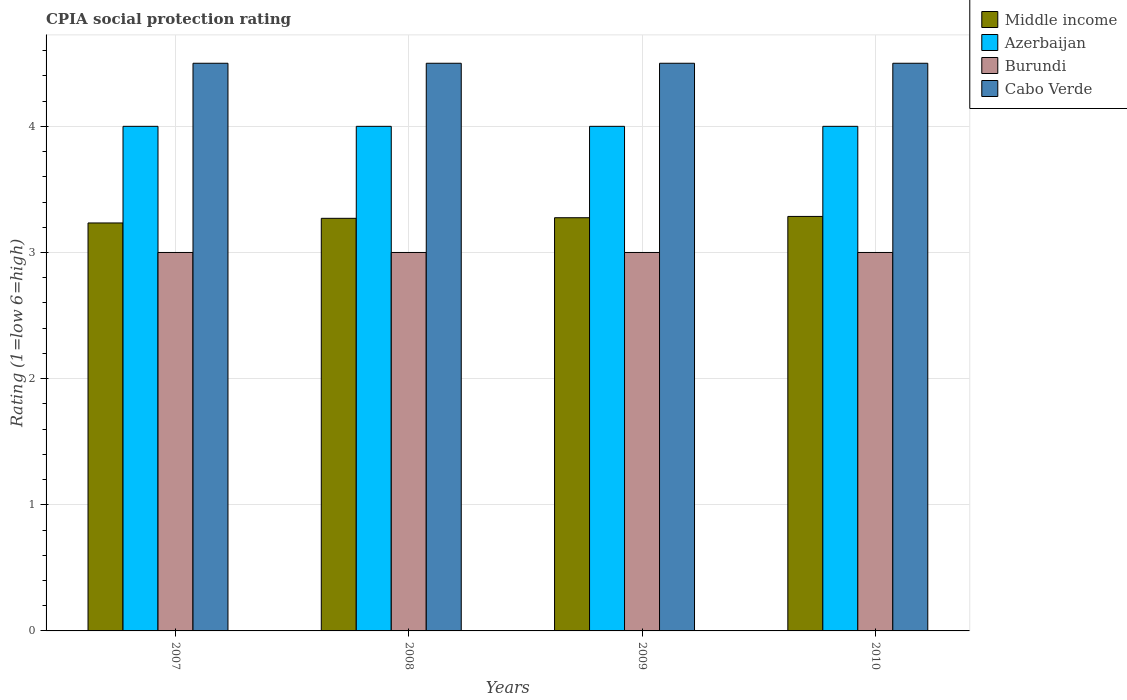Are the number of bars per tick equal to the number of legend labels?
Make the answer very short. Yes. What is the label of the 4th group of bars from the left?
Give a very brief answer. 2010. In which year was the CPIA rating in Cabo Verde maximum?
Keep it short and to the point. 2007. What is the total CPIA rating in Burundi in the graph?
Provide a short and direct response. 12. What is the difference between the CPIA rating in Azerbaijan in 2008 and that in 2010?
Your answer should be compact. 0. What is the difference between the CPIA rating in Cabo Verde in 2008 and the CPIA rating in Azerbaijan in 2009?
Give a very brief answer. 0.5. What is the average CPIA rating in Middle income per year?
Your answer should be very brief. 3.27. In the year 2007, what is the difference between the CPIA rating in Middle income and CPIA rating in Azerbaijan?
Your answer should be compact. -0.77. What is the ratio of the CPIA rating in Middle income in 2007 to that in 2008?
Make the answer very short. 0.99. What is the difference between the highest and the lowest CPIA rating in Middle income?
Offer a terse response. 0.05. In how many years, is the CPIA rating in Azerbaijan greater than the average CPIA rating in Azerbaijan taken over all years?
Offer a terse response. 0. Is the sum of the CPIA rating in Cabo Verde in 2007 and 2008 greater than the maximum CPIA rating in Burundi across all years?
Offer a terse response. Yes. What does the 1st bar from the left in 2007 represents?
Your answer should be compact. Middle income. What does the 1st bar from the right in 2008 represents?
Provide a short and direct response. Cabo Verde. How many bars are there?
Provide a succinct answer. 16. Are all the bars in the graph horizontal?
Ensure brevity in your answer.  No. How many years are there in the graph?
Keep it short and to the point. 4. What is the difference between two consecutive major ticks on the Y-axis?
Offer a very short reply. 1. Are the values on the major ticks of Y-axis written in scientific E-notation?
Keep it short and to the point. No. Where does the legend appear in the graph?
Your answer should be compact. Top right. How many legend labels are there?
Your answer should be very brief. 4. How are the legend labels stacked?
Your response must be concise. Vertical. What is the title of the graph?
Your answer should be compact. CPIA social protection rating. What is the label or title of the X-axis?
Keep it short and to the point. Years. What is the label or title of the Y-axis?
Your answer should be very brief. Rating (1=low 6=high). What is the Rating (1=low 6=high) in Middle income in 2007?
Ensure brevity in your answer.  3.23. What is the Rating (1=low 6=high) of Middle income in 2008?
Offer a terse response. 3.27. What is the Rating (1=low 6=high) of Azerbaijan in 2008?
Keep it short and to the point. 4. What is the Rating (1=low 6=high) in Burundi in 2008?
Your response must be concise. 3. What is the Rating (1=low 6=high) of Cabo Verde in 2008?
Make the answer very short. 4.5. What is the Rating (1=low 6=high) of Middle income in 2009?
Keep it short and to the point. 3.28. What is the Rating (1=low 6=high) in Burundi in 2009?
Give a very brief answer. 3. What is the Rating (1=low 6=high) of Middle income in 2010?
Provide a succinct answer. 3.29. What is the Rating (1=low 6=high) of Azerbaijan in 2010?
Provide a short and direct response. 4. Across all years, what is the maximum Rating (1=low 6=high) of Middle income?
Offer a very short reply. 3.29. Across all years, what is the minimum Rating (1=low 6=high) in Middle income?
Your answer should be compact. 3.23. Across all years, what is the minimum Rating (1=low 6=high) in Burundi?
Offer a terse response. 3. Across all years, what is the minimum Rating (1=low 6=high) in Cabo Verde?
Keep it short and to the point. 4.5. What is the total Rating (1=low 6=high) in Middle income in the graph?
Your response must be concise. 13.07. What is the total Rating (1=low 6=high) in Azerbaijan in the graph?
Your answer should be compact. 16. What is the total Rating (1=low 6=high) in Cabo Verde in the graph?
Make the answer very short. 18. What is the difference between the Rating (1=low 6=high) in Middle income in 2007 and that in 2008?
Provide a short and direct response. -0.04. What is the difference between the Rating (1=low 6=high) in Burundi in 2007 and that in 2008?
Your response must be concise. 0. What is the difference between the Rating (1=low 6=high) of Middle income in 2007 and that in 2009?
Your response must be concise. -0.04. What is the difference between the Rating (1=low 6=high) in Burundi in 2007 and that in 2009?
Offer a very short reply. 0. What is the difference between the Rating (1=low 6=high) in Middle income in 2007 and that in 2010?
Your answer should be very brief. -0.05. What is the difference between the Rating (1=low 6=high) in Azerbaijan in 2007 and that in 2010?
Your answer should be compact. 0. What is the difference between the Rating (1=low 6=high) in Middle income in 2008 and that in 2009?
Keep it short and to the point. -0. What is the difference between the Rating (1=low 6=high) of Azerbaijan in 2008 and that in 2009?
Offer a terse response. 0. What is the difference between the Rating (1=low 6=high) in Burundi in 2008 and that in 2009?
Your answer should be compact. 0. What is the difference between the Rating (1=low 6=high) in Cabo Verde in 2008 and that in 2009?
Make the answer very short. 0. What is the difference between the Rating (1=low 6=high) of Middle income in 2008 and that in 2010?
Provide a short and direct response. -0.01. What is the difference between the Rating (1=low 6=high) of Azerbaijan in 2008 and that in 2010?
Offer a terse response. 0. What is the difference between the Rating (1=low 6=high) of Middle income in 2009 and that in 2010?
Your answer should be compact. -0.01. What is the difference between the Rating (1=low 6=high) of Azerbaijan in 2009 and that in 2010?
Keep it short and to the point. 0. What is the difference between the Rating (1=low 6=high) in Burundi in 2009 and that in 2010?
Provide a short and direct response. 0. What is the difference between the Rating (1=low 6=high) in Middle income in 2007 and the Rating (1=low 6=high) in Azerbaijan in 2008?
Your answer should be compact. -0.77. What is the difference between the Rating (1=low 6=high) of Middle income in 2007 and the Rating (1=low 6=high) of Burundi in 2008?
Offer a terse response. 0.23. What is the difference between the Rating (1=low 6=high) of Middle income in 2007 and the Rating (1=low 6=high) of Cabo Verde in 2008?
Provide a short and direct response. -1.27. What is the difference between the Rating (1=low 6=high) in Azerbaijan in 2007 and the Rating (1=low 6=high) in Cabo Verde in 2008?
Your answer should be compact. -0.5. What is the difference between the Rating (1=low 6=high) in Middle income in 2007 and the Rating (1=low 6=high) in Azerbaijan in 2009?
Offer a terse response. -0.77. What is the difference between the Rating (1=low 6=high) of Middle income in 2007 and the Rating (1=low 6=high) of Burundi in 2009?
Provide a succinct answer. 0.23. What is the difference between the Rating (1=low 6=high) of Middle income in 2007 and the Rating (1=low 6=high) of Cabo Verde in 2009?
Keep it short and to the point. -1.27. What is the difference between the Rating (1=low 6=high) of Azerbaijan in 2007 and the Rating (1=low 6=high) of Cabo Verde in 2009?
Provide a short and direct response. -0.5. What is the difference between the Rating (1=low 6=high) of Middle income in 2007 and the Rating (1=low 6=high) of Azerbaijan in 2010?
Make the answer very short. -0.77. What is the difference between the Rating (1=low 6=high) of Middle income in 2007 and the Rating (1=low 6=high) of Burundi in 2010?
Your answer should be very brief. 0.23. What is the difference between the Rating (1=low 6=high) of Middle income in 2007 and the Rating (1=low 6=high) of Cabo Verde in 2010?
Offer a very short reply. -1.27. What is the difference between the Rating (1=low 6=high) in Azerbaijan in 2007 and the Rating (1=low 6=high) in Cabo Verde in 2010?
Provide a short and direct response. -0.5. What is the difference between the Rating (1=low 6=high) in Middle income in 2008 and the Rating (1=low 6=high) in Azerbaijan in 2009?
Provide a succinct answer. -0.73. What is the difference between the Rating (1=low 6=high) in Middle income in 2008 and the Rating (1=low 6=high) in Burundi in 2009?
Keep it short and to the point. 0.27. What is the difference between the Rating (1=low 6=high) of Middle income in 2008 and the Rating (1=low 6=high) of Cabo Verde in 2009?
Offer a terse response. -1.23. What is the difference between the Rating (1=low 6=high) in Middle income in 2008 and the Rating (1=low 6=high) in Azerbaijan in 2010?
Offer a very short reply. -0.73. What is the difference between the Rating (1=low 6=high) in Middle income in 2008 and the Rating (1=low 6=high) in Burundi in 2010?
Provide a short and direct response. 0.27. What is the difference between the Rating (1=low 6=high) of Middle income in 2008 and the Rating (1=low 6=high) of Cabo Verde in 2010?
Give a very brief answer. -1.23. What is the difference between the Rating (1=low 6=high) in Azerbaijan in 2008 and the Rating (1=low 6=high) in Burundi in 2010?
Ensure brevity in your answer.  1. What is the difference between the Rating (1=low 6=high) of Azerbaijan in 2008 and the Rating (1=low 6=high) of Cabo Verde in 2010?
Keep it short and to the point. -0.5. What is the difference between the Rating (1=low 6=high) of Middle income in 2009 and the Rating (1=low 6=high) of Azerbaijan in 2010?
Offer a very short reply. -0.72. What is the difference between the Rating (1=low 6=high) in Middle income in 2009 and the Rating (1=low 6=high) in Burundi in 2010?
Your response must be concise. 0.28. What is the difference between the Rating (1=low 6=high) of Middle income in 2009 and the Rating (1=low 6=high) of Cabo Verde in 2010?
Offer a very short reply. -1.22. What is the difference between the Rating (1=low 6=high) of Azerbaijan in 2009 and the Rating (1=low 6=high) of Burundi in 2010?
Offer a terse response. 1. What is the difference between the Rating (1=low 6=high) in Azerbaijan in 2009 and the Rating (1=low 6=high) in Cabo Verde in 2010?
Offer a terse response. -0.5. What is the difference between the Rating (1=low 6=high) in Burundi in 2009 and the Rating (1=low 6=high) in Cabo Verde in 2010?
Give a very brief answer. -1.5. What is the average Rating (1=low 6=high) in Middle income per year?
Offer a terse response. 3.27. What is the average Rating (1=low 6=high) in Burundi per year?
Provide a succinct answer. 3. In the year 2007, what is the difference between the Rating (1=low 6=high) in Middle income and Rating (1=low 6=high) in Azerbaijan?
Your response must be concise. -0.77. In the year 2007, what is the difference between the Rating (1=low 6=high) of Middle income and Rating (1=low 6=high) of Burundi?
Your answer should be very brief. 0.23. In the year 2007, what is the difference between the Rating (1=low 6=high) in Middle income and Rating (1=low 6=high) in Cabo Verde?
Keep it short and to the point. -1.27. In the year 2007, what is the difference between the Rating (1=low 6=high) in Azerbaijan and Rating (1=low 6=high) in Cabo Verde?
Offer a terse response. -0.5. In the year 2007, what is the difference between the Rating (1=low 6=high) of Burundi and Rating (1=low 6=high) of Cabo Verde?
Your answer should be compact. -1.5. In the year 2008, what is the difference between the Rating (1=low 6=high) in Middle income and Rating (1=low 6=high) in Azerbaijan?
Provide a short and direct response. -0.73. In the year 2008, what is the difference between the Rating (1=low 6=high) of Middle income and Rating (1=low 6=high) of Burundi?
Provide a short and direct response. 0.27. In the year 2008, what is the difference between the Rating (1=low 6=high) in Middle income and Rating (1=low 6=high) in Cabo Verde?
Your answer should be compact. -1.23. In the year 2008, what is the difference between the Rating (1=low 6=high) in Azerbaijan and Rating (1=low 6=high) in Cabo Verde?
Offer a very short reply. -0.5. In the year 2008, what is the difference between the Rating (1=low 6=high) of Burundi and Rating (1=low 6=high) of Cabo Verde?
Keep it short and to the point. -1.5. In the year 2009, what is the difference between the Rating (1=low 6=high) in Middle income and Rating (1=low 6=high) in Azerbaijan?
Offer a terse response. -0.72. In the year 2009, what is the difference between the Rating (1=low 6=high) in Middle income and Rating (1=low 6=high) in Burundi?
Provide a short and direct response. 0.28. In the year 2009, what is the difference between the Rating (1=low 6=high) in Middle income and Rating (1=low 6=high) in Cabo Verde?
Offer a terse response. -1.22. In the year 2009, what is the difference between the Rating (1=low 6=high) in Azerbaijan and Rating (1=low 6=high) in Burundi?
Offer a terse response. 1. In the year 2009, what is the difference between the Rating (1=low 6=high) of Azerbaijan and Rating (1=low 6=high) of Cabo Verde?
Your response must be concise. -0.5. In the year 2010, what is the difference between the Rating (1=low 6=high) in Middle income and Rating (1=low 6=high) in Azerbaijan?
Offer a terse response. -0.71. In the year 2010, what is the difference between the Rating (1=low 6=high) in Middle income and Rating (1=low 6=high) in Burundi?
Offer a very short reply. 0.29. In the year 2010, what is the difference between the Rating (1=low 6=high) in Middle income and Rating (1=low 6=high) in Cabo Verde?
Your answer should be compact. -1.21. In the year 2010, what is the difference between the Rating (1=low 6=high) of Azerbaijan and Rating (1=low 6=high) of Burundi?
Your answer should be compact. 1. What is the ratio of the Rating (1=low 6=high) in Azerbaijan in 2007 to that in 2008?
Your response must be concise. 1. What is the ratio of the Rating (1=low 6=high) in Burundi in 2007 to that in 2008?
Your answer should be compact. 1. What is the ratio of the Rating (1=low 6=high) in Middle income in 2007 to that in 2009?
Offer a terse response. 0.99. What is the ratio of the Rating (1=low 6=high) in Burundi in 2007 to that in 2009?
Keep it short and to the point. 1. What is the ratio of the Rating (1=low 6=high) of Cabo Verde in 2007 to that in 2009?
Offer a terse response. 1. What is the ratio of the Rating (1=low 6=high) in Middle income in 2007 to that in 2010?
Provide a short and direct response. 0.98. What is the ratio of the Rating (1=low 6=high) of Burundi in 2007 to that in 2010?
Offer a very short reply. 1. What is the ratio of the Rating (1=low 6=high) in Middle income in 2008 to that in 2009?
Offer a very short reply. 1. What is the ratio of the Rating (1=low 6=high) in Cabo Verde in 2008 to that in 2009?
Make the answer very short. 1. What is the ratio of the Rating (1=low 6=high) of Azerbaijan in 2008 to that in 2010?
Your answer should be compact. 1. What is the ratio of the Rating (1=low 6=high) of Cabo Verde in 2008 to that in 2010?
Your answer should be very brief. 1. What is the ratio of the Rating (1=low 6=high) in Azerbaijan in 2009 to that in 2010?
Provide a succinct answer. 1. What is the difference between the highest and the second highest Rating (1=low 6=high) of Middle income?
Keep it short and to the point. 0.01. What is the difference between the highest and the second highest Rating (1=low 6=high) in Azerbaijan?
Provide a short and direct response. 0. What is the difference between the highest and the second highest Rating (1=low 6=high) in Cabo Verde?
Your answer should be compact. 0. What is the difference between the highest and the lowest Rating (1=low 6=high) of Middle income?
Provide a short and direct response. 0.05. What is the difference between the highest and the lowest Rating (1=low 6=high) in Cabo Verde?
Your answer should be very brief. 0. 